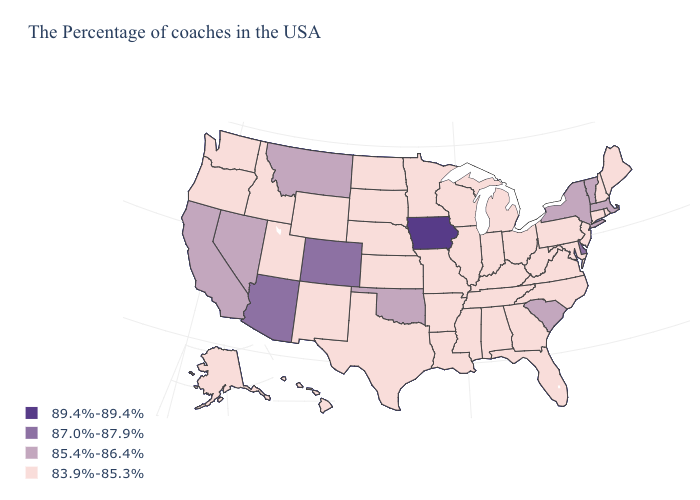Among the states that border South Dakota , does Minnesota have the highest value?
Quick response, please. No. What is the value of Illinois?
Write a very short answer. 83.9%-85.3%. What is the lowest value in the USA?
Write a very short answer. 83.9%-85.3%. Does Colorado have the lowest value in the USA?
Quick response, please. No. What is the value of Utah?
Write a very short answer. 83.9%-85.3%. What is the value of Nebraska?
Answer briefly. 83.9%-85.3%. Is the legend a continuous bar?
Keep it brief. No. Does Vermont have the lowest value in the USA?
Be succinct. No. Does Vermont have the lowest value in the Northeast?
Give a very brief answer. No. What is the value of New Hampshire?
Short answer required. 83.9%-85.3%. What is the value of Louisiana?
Be succinct. 83.9%-85.3%. What is the value of Michigan?
Concise answer only. 83.9%-85.3%. Does Iowa have the highest value in the USA?
Concise answer only. Yes. How many symbols are there in the legend?
Concise answer only. 4. Is the legend a continuous bar?
Be succinct. No. 